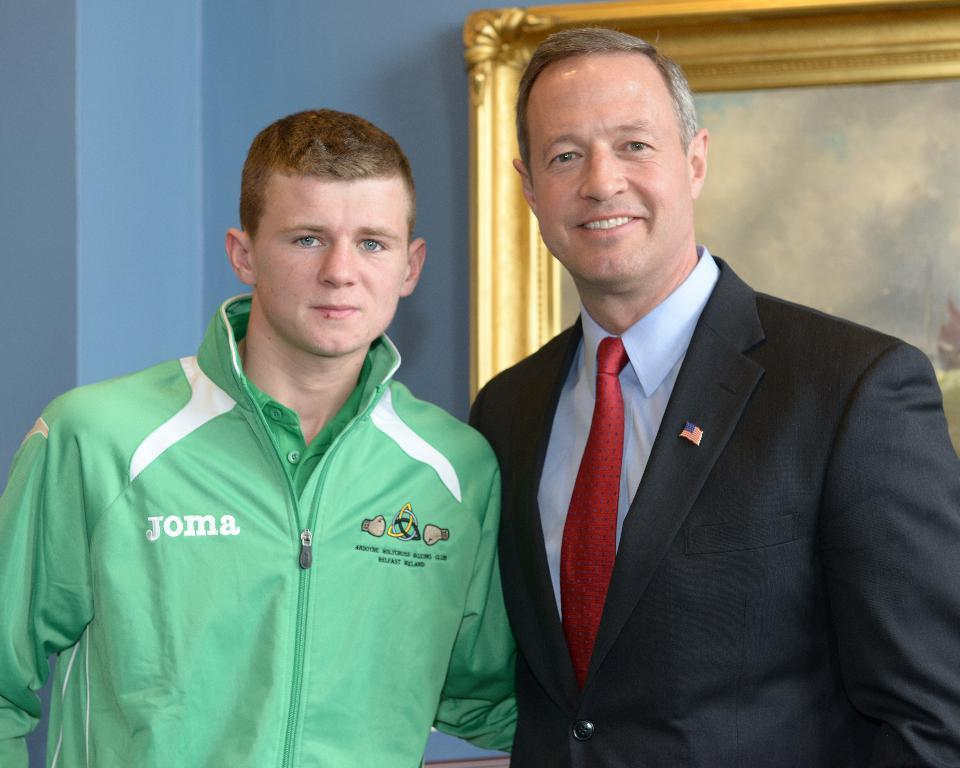<image>
Share a concise interpretation of the image provided. A young man in a green shirt with Joma on the chest poses for a photo with an older man in a suit. 